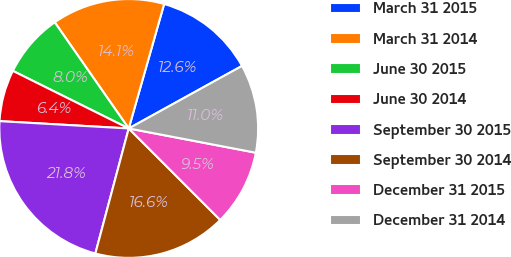Convert chart. <chart><loc_0><loc_0><loc_500><loc_500><pie_chart><fcel>March 31 2015<fcel>March 31 2014<fcel>June 30 2015<fcel>June 30 2014<fcel>September 30 2015<fcel>September 30 2014<fcel>December 31 2015<fcel>December 31 2014<nl><fcel>12.56%<fcel>14.1%<fcel>7.97%<fcel>6.44%<fcel>21.75%<fcel>16.65%<fcel>9.5%<fcel>11.03%<nl></chart> 